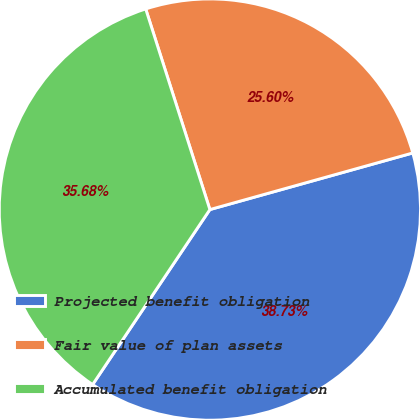Convert chart to OTSL. <chart><loc_0><loc_0><loc_500><loc_500><pie_chart><fcel>Projected benefit obligation<fcel>Fair value of plan assets<fcel>Accumulated benefit obligation<nl><fcel>38.73%<fcel>25.6%<fcel>35.68%<nl></chart> 